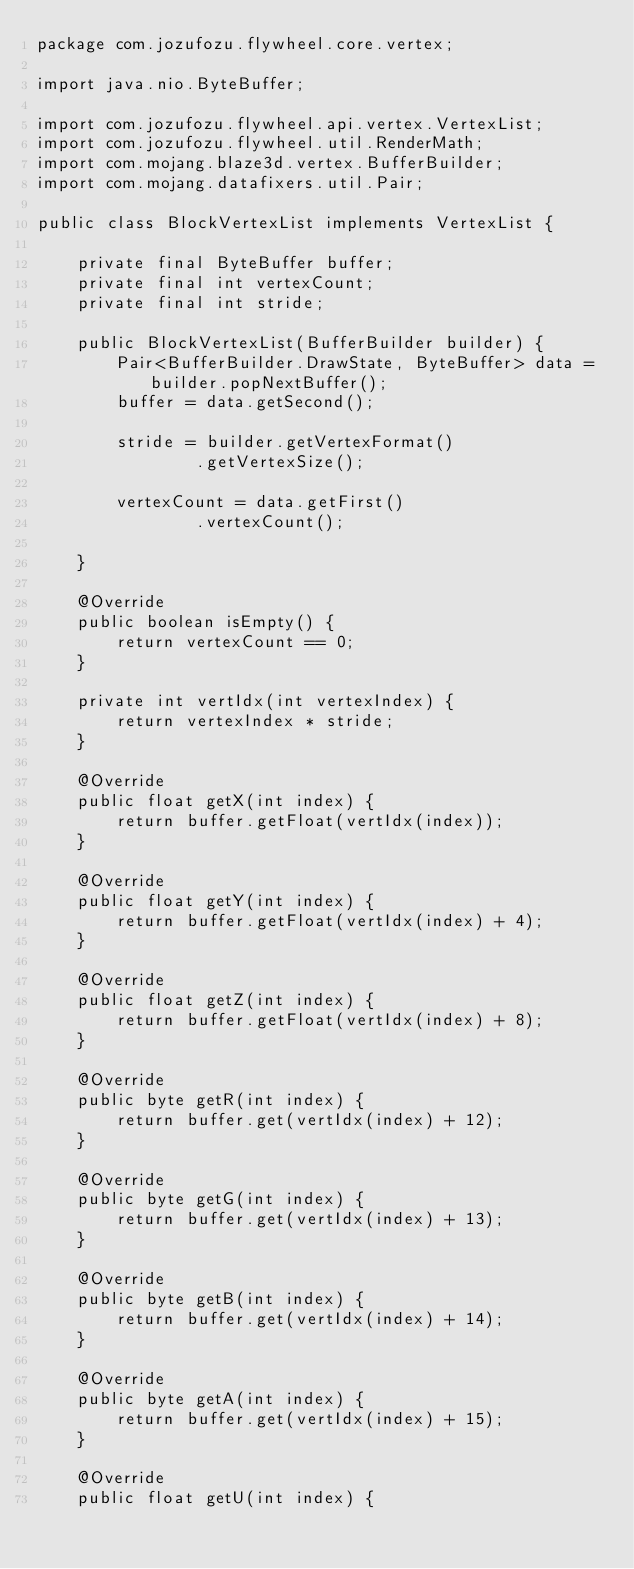<code> <loc_0><loc_0><loc_500><loc_500><_Java_>package com.jozufozu.flywheel.core.vertex;

import java.nio.ByteBuffer;

import com.jozufozu.flywheel.api.vertex.VertexList;
import com.jozufozu.flywheel.util.RenderMath;
import com.mojang.blaze3d.vertex.BufferBuilder;
import com.mojang.datafixers.util.Pair;

public class BlockVertexList implements VertexList {

	private final ByteBuffer buffer;
	private final int vertexCount;
	private final int stride;

	public BlockVertexList(BufferBuilder builder) {
		Pair<BufferBuilder.DrawState, ByteBuffer> data = builder.popNextBuffer();
		buffer = data.getSecond();

		stride = builder.getVertexFormat()
				.getVertexSize();

		vertexCount = data.getFirst()
				.vertexCount();

	}

	@Override
	public boolean isEmpty() {
		return vertexCount == 0;
	}

	private int vertIdx(int vertexIndex) {
		return vertexIndex * stride;
	}

	@Override
	public float getX(int index) {
		return buffer.getFloat(vertIdx(index));
	}

	@Override
	public float getY(int index) {
		return buffer.getFloat(vertIdx(index) + 4);
	}

	@Override
	public float getZ(int index) {
		return buffer.getFloat(vertIdx(index) + 8);
	}

	@Override
	public byte getR(int index) {
		return buffer.get(vertIdx(index) + 12);
	}

	@Override
	public byte getG(int index) {
		return buffer.get(vertIdx(index) + 13);
	}

	@Override
	public byte getB(int index) {
		return buffer.get(vertIdx(index) + 14);
	}

	@Override
	public byte getA(int index) {
		return buffer.get(vertIdx(index) + 15);
	}

	@Override
	public float getU(int index) {</code> 